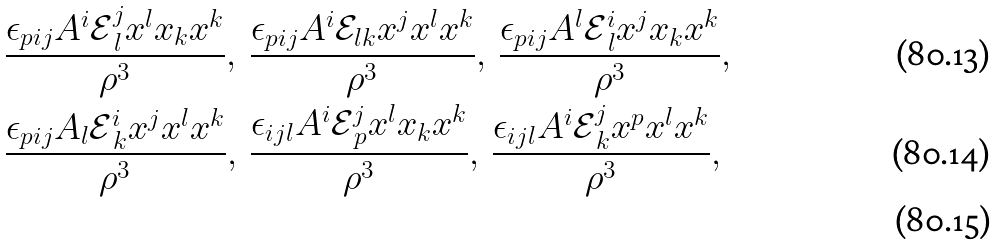Convert formula to latex. <formula><loc_0><loc_0><loc_500><loc_500>& \frac { \epsilon _ { p i j } A ^ { i } \mathcal { E } ^ { j } _ { \, l } x ^ { l } x _ { k } x ^ { k } } { \rho ^ { 3 } } , \, \frac { \epsilon _ { p i j } A ^ { i } \mathcal { E } _ { l k } x ^ { j } x ^ { l } x ^ { k } } { \rho ^ { 3 } } , \, \frac { \epsilon _ { p i j } A ^ { l } \mathcal { E } ^ { i } _ { \, l } x ^ { j } x _ { k } x ^ { k } } { \rho ^ { 3 } } , \\ & \frac { \epsilon _ { p i j } A _ { l } \mathcal { E } ^ { i } _ { \, k } x ^ { j } x ^ { l } x ^ { k } } { \rho ^ { 3 } } , \, \frac { \epsilon _ { i j l } A ^ { i } \mathcal { E } ^ { j } _ { \, p } x ^ { l } x _ { k } x ^ { k } } { \rho ^ { 3 } } , \, \frac { \epsilon _ { i j l } A ^ { i } \mathcal { E } ^ { j } _ { \, k } x ^ { p } x ^ { l } x ^ { k } } { \rho ^ { 3 } } , \\</formula> 